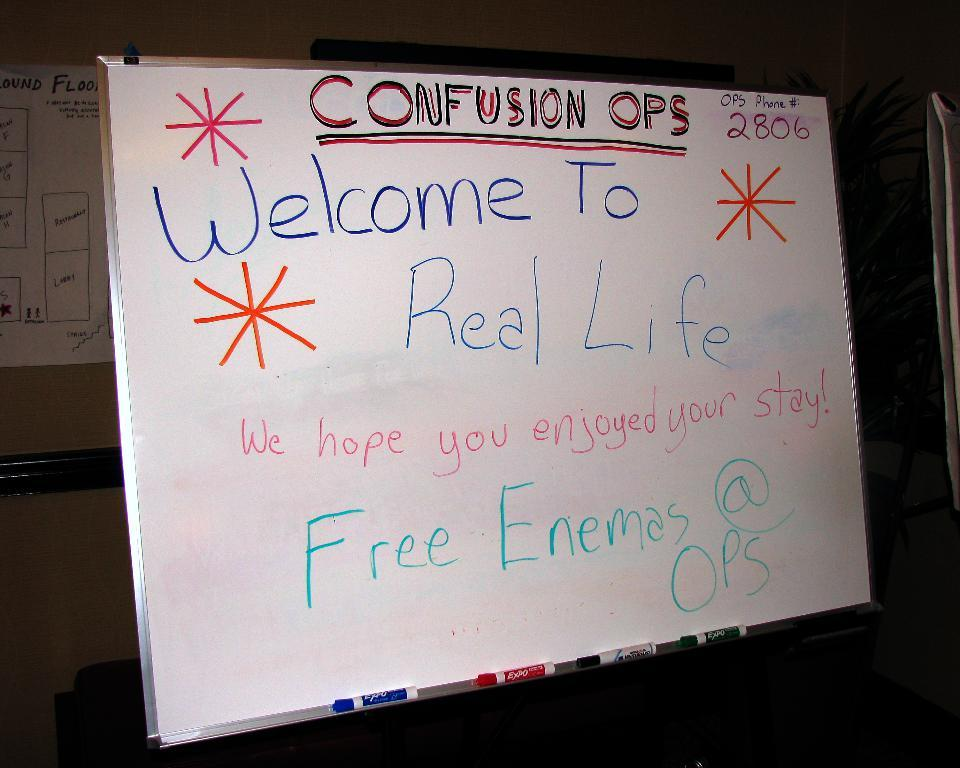Provide a one-sentence caption for the provided image. a poster someone wrote CONFUSION OPS "Welcome To Real Life We hope you enjoyed your stay!" Free Enamas @OPS & OPS Phone #: 2806. 